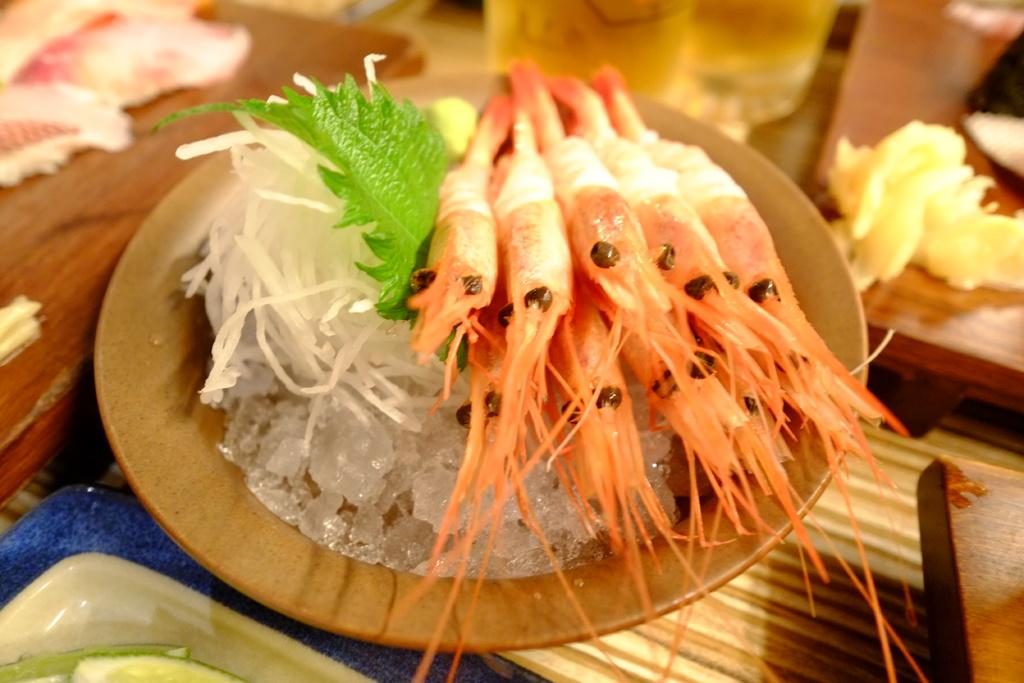What is present on the plate in the image? There is a food item on the plate in the image. Where is the plate located? The plate is placed on a table. Are there any other plates visible in the image? Yes, there is another plate on the table. What type of jelly is being used to invent a new musical instrument in the image? There is no jelly, invention, or musical instrument present in the image. 